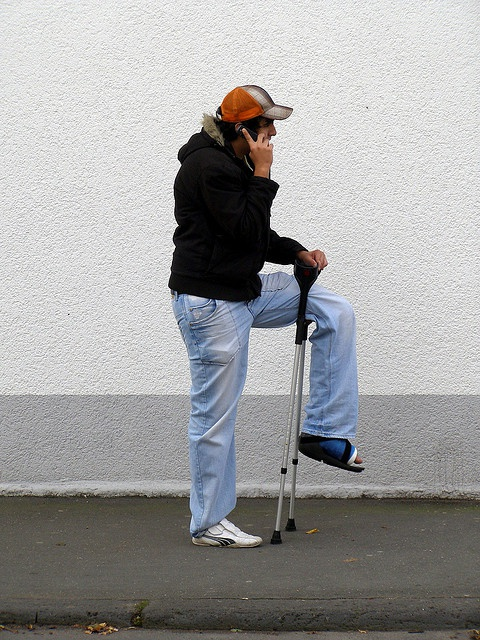Describe the objects in this image and their specific colors. I can see people in lightgray, black, darkgray, and gray tones and cell phone in lightgray, black, maroon, and gray tones in this image. 